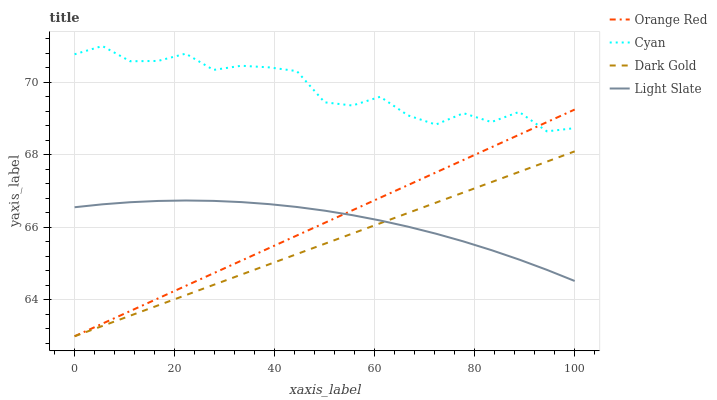Does Orange Red have the minimum area under the curve?
Answer yes or no. No. Does Orange Red have the maximum area under the curve?
Answer yes or no. No. Is Orange Red the smoothest?
Answer yes or no. No. Is Orange Red the roughest?
Answer yes or no. No. Does Cyan have the lowest value?
Answer yes or no. No. Does Orange Red have the highest value?
Answer yes or no. No. Is Dark Gold less than Cyan?
Answer yes or no. Yes. Is Cyan greater than Light Slate?
Answer yes or no. Yes. Does Dark Gold intersect Cyan?
Answer yes or no. No. 